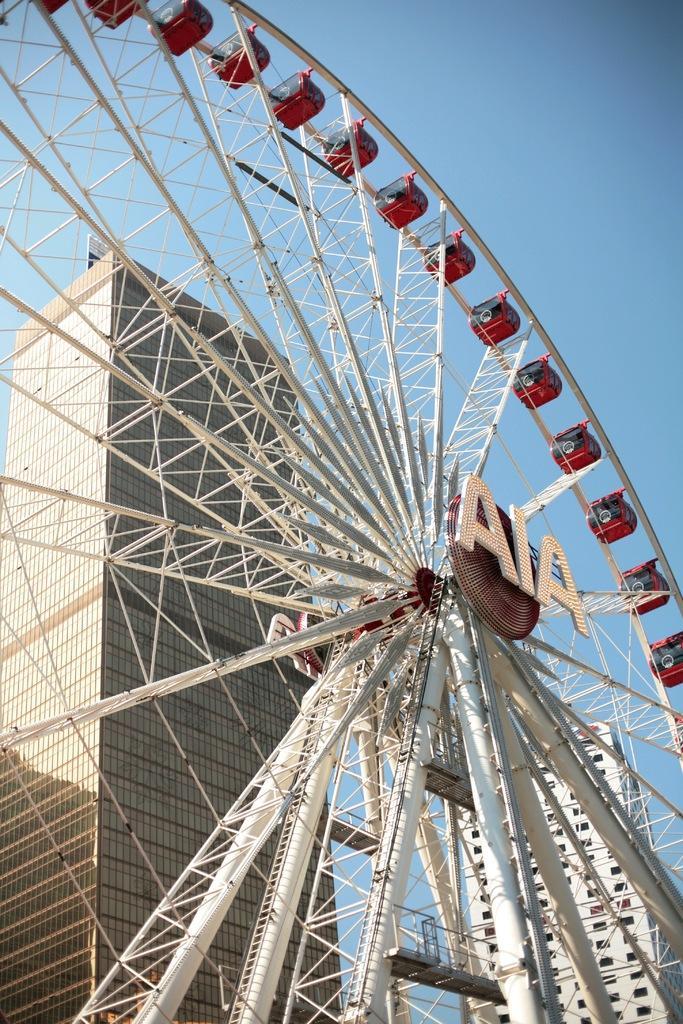Can you describe this image briefly? In this image there is a giant wheel. In the background there is a building. At the top there is sky. In the middle of the giant wheel there is a hoarding. 